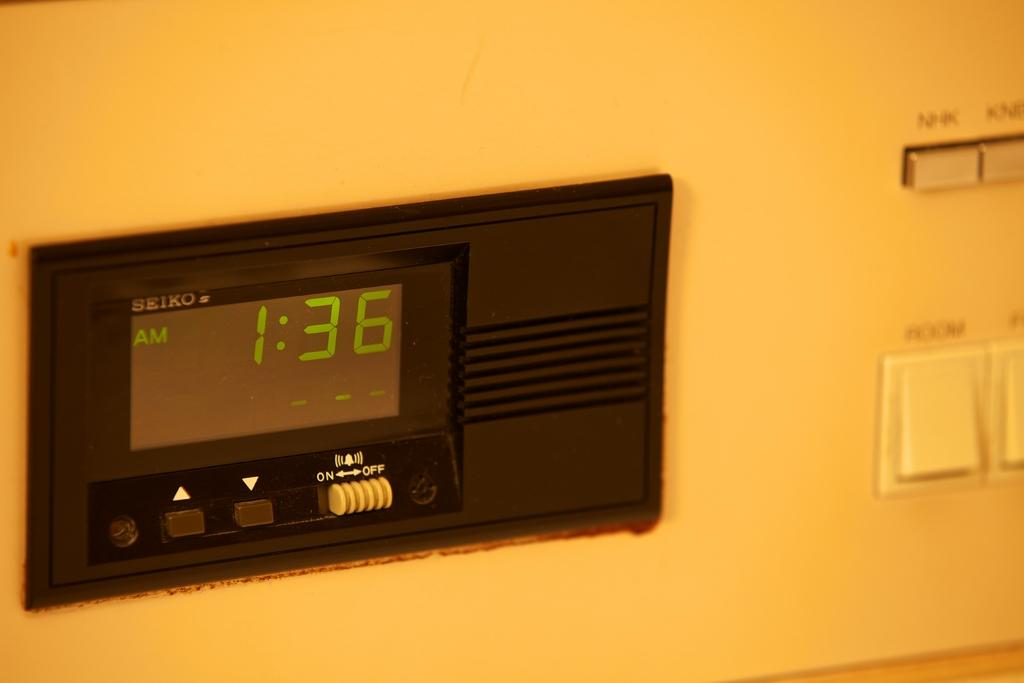<image>
Create a compact narrative representing the image presented. A black clock face shows the time of 1:36 AM. 